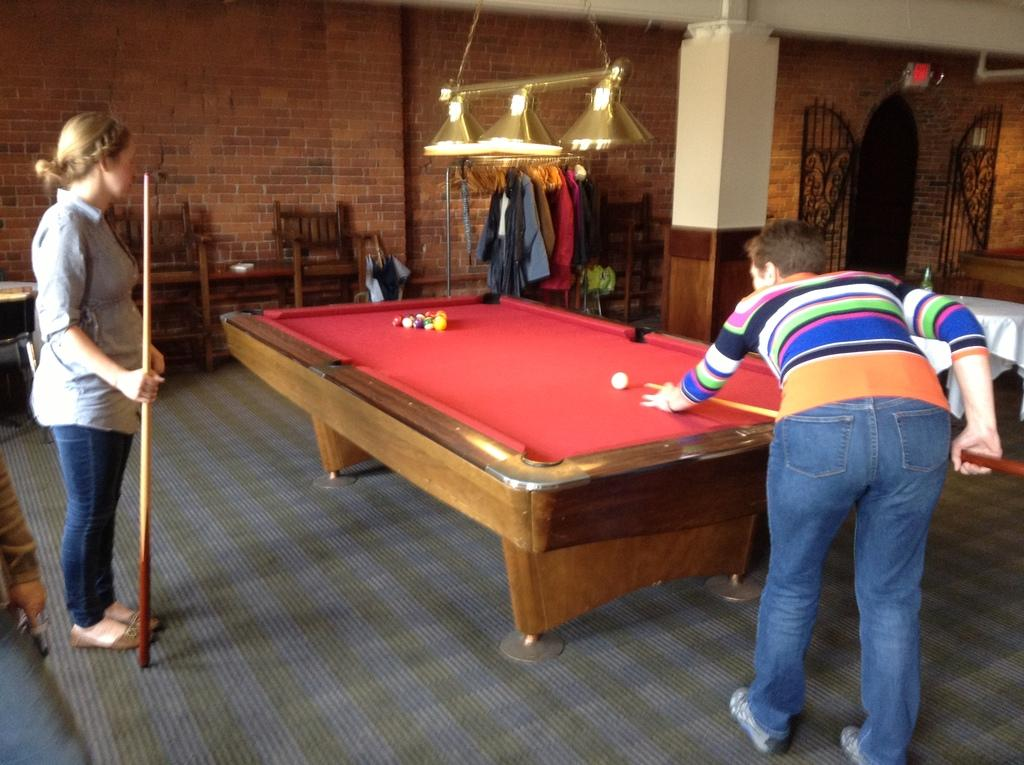How many people are present in the image? There are two women in the image. What activity are the women engaged in? The women are playing billiards. What is the name of the harbor where the women are playing billiards? There is no harbor present in the image, as the women are playing billiards indoors. What type of seed is being used as a prop in the image? There are no seeds present in the image; the women are playing billiards with billiard balls. 